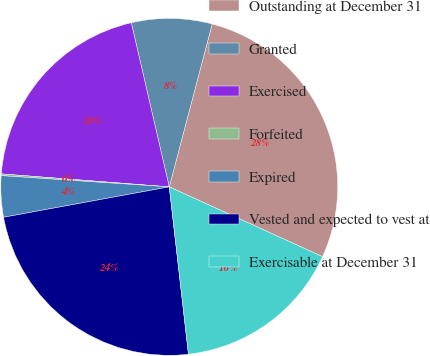<chart> <loc_0><loc_0><loc_500><loc_500><pie_chart><fcel>Outstanding at December 31<fcel>Granted<fcel>Exercised<fcel>Forfeited<fcel>Expired<fcel>Vested and expected to vest at<fcel>Exercisable at December 31<nl><fcel>27.7%<fcel>7.72%<fcel>20.15%<fcel>0.17%<fcel>3.95%<fcel>23.93%<fcel>16.38%<nl></chart> 